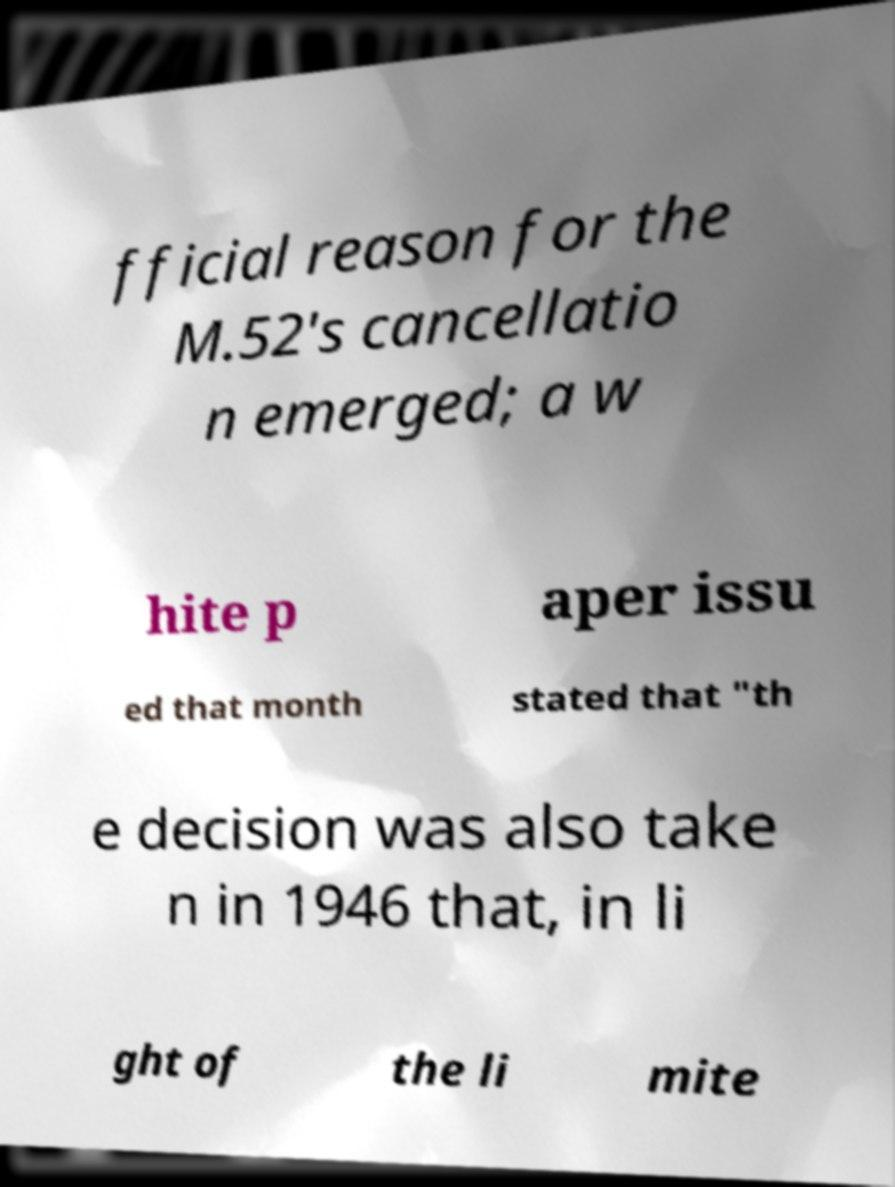There's text embedded in this image that I need extracted. Can you transcribe it verbatim? fficial reason for the M.52's cancellatio n emerged; a w hite p aper issu ed that month stated that "th e decision was also take n in 1946 that, in li ght of the li mite 